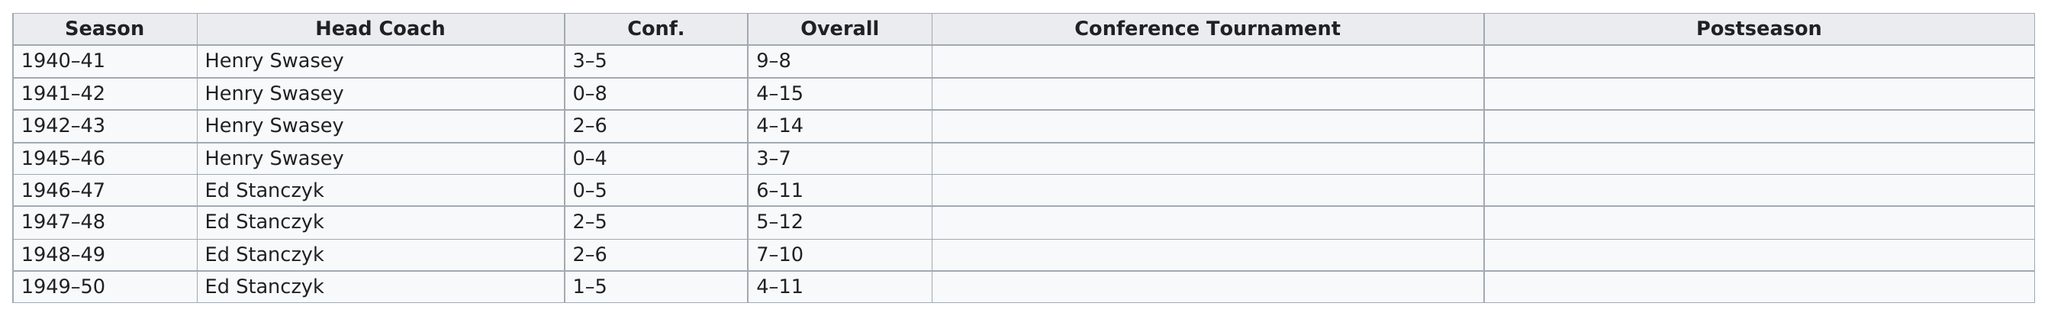Outline some significant characteristics in this image. For away games, the team wears a blue uniform, whereas for home games, they wear a different uniform in a different color. Blue and white are the two colors that can be worn for both home and away games. The color that is next to blue is white. 